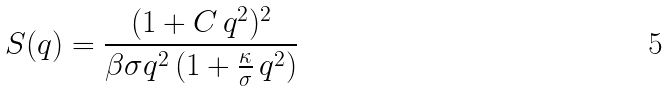Convert formula to latex. <formula><loc_0><loc_0><loc_500><loc_500>S ( q ) = \frac { ( 1 + C \, q ^ { 2 } ) ^ { 2 } } { \beta \sigma q ^ { 2 } \, ( 1 + \frac { \kappa } { \sigma } \, q ^ { 2 } ) }</formula> 